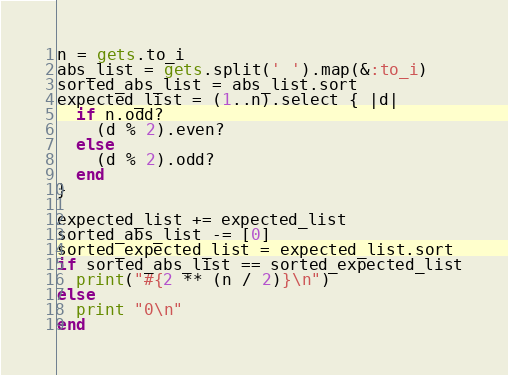<code> <loc_0><loc_0><loc_500><loc_500><_Ruby_>n = gets.to_i
abs_list = gets.split(' ').map(&:to_i)
sorted_abs_list = abs_list.sort
expected_list = (1..n).select { |d|
  if n.odd?
    (d % 2).even?
  else
    (d % 2).odd?
  end
}

expected_list += expected_list
sorted_abs_list -= [0]
sorted_expected_list = expected_list.sort
if sorted_abs_list == sorted_expected_list
  print("#{2 ** (n / 2)}\n")
else
  print "0\n"
end</code> 